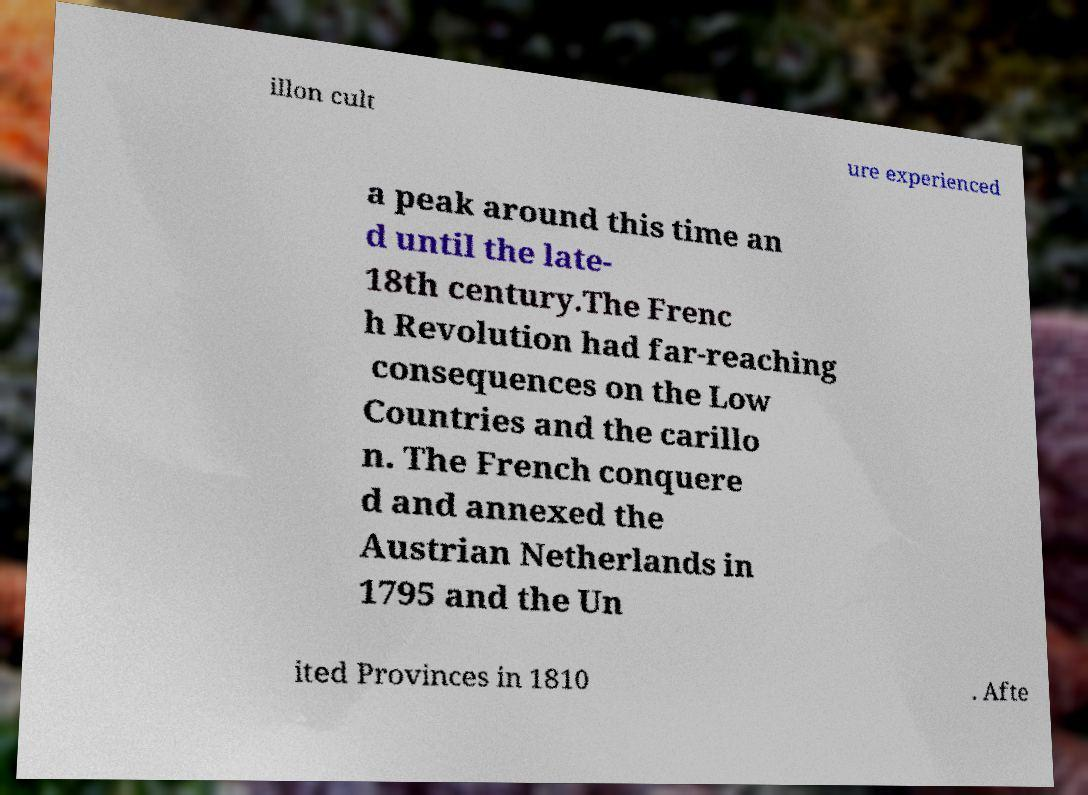For documentation purposes, I need the text within this image transcribed. Could you provide that? illon cult ure experienced a peak around this time an d until the late- 18th century.The Frenc h Revolution had far-reaching consequences on the Low Countries and the carillo n. The French conquere d and annexed the Austrian Netherlands in 1795 and the Un ited Provinces in 1810 . Afte 